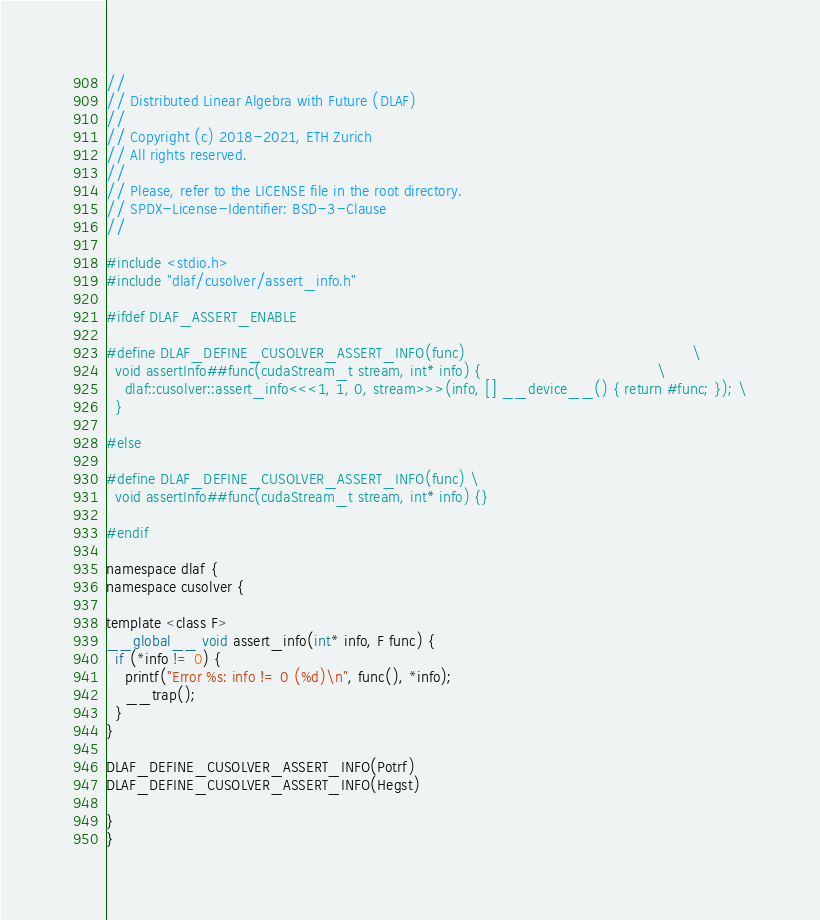Convert code to text. <code><loc_0><loc_0><loc_500><loc_500><_Cuda_>//
// Distributed Linear Algebra with Future (DLAF)
//
// Copyright (c) 2018-2021, ETH Zurich
// All rights reserved.
//
// Please, refer to the LICENSE file in the root directory.
// SPDX-License-Identifier: BSD-3-Clause
//

#include <stdio.h>
#include "dlaf/cusolver/assert_info.h"

#ifdef DLAF_ASSERT_ENABLE

#define DLAF_DEFINE_CUSOLVER_ASSERT_INFO(func)                                                 \
  void assertInfo##func(cudaStream_t stream, int* info) {                                      \
    dlaf::cusolver::assert_info<<<1, 1, 0, stream>>>(info, [] __device__() { return #func; }); \
  }

#else

#define DLAF_DEFINE_CUSOLVER_ASSERT_INFO(func) \
  void assertInfo##func(cudaStream_t stream, int* info) {}

#endif

namespace dlaf {
namespace cusolver {

template <class F>
__global__ void assert_info(int* info, F func) {
  if (*info != 0) {
    printf("Error %s: info != 0 (%d)\n", func(), *info);
    __trap();
  }
}

DLAF_DEFINE_CUSOLVER_ASSERT_INFO(Potrf)
DLAF_DEFINE_CUSOLVER_ASSERT_INFO(Hegst)

}
}
</code> 